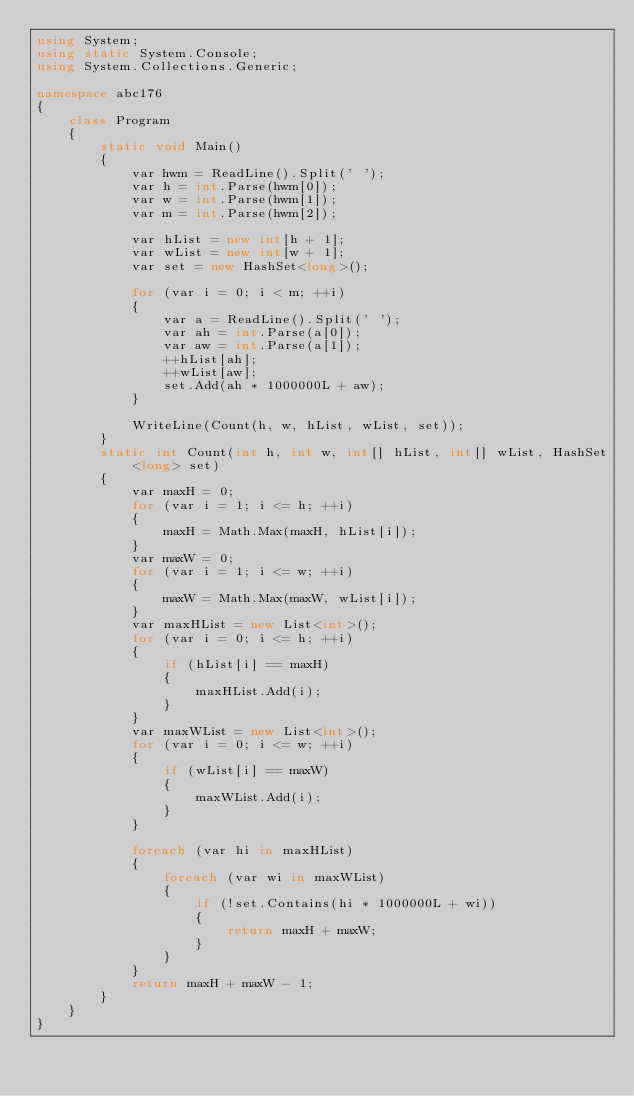<code> <loc_0><loc_0><loc_500><loc_500><_C#_>using System;
using static System.Console;
using System.Collections.Generic;

namespace abc176
{
    class Program
    {
        static void Main()
        {
            var hwm = ReadLine().Split(' ');
            var h = int.Parse(hwm[0]);
            var w = int.Parse(hwm[1]);
            var m = int.Parse(hwm[2]);

            var hList = new int[h + 1];
            var wList = new int[w + 1];
            var set = new HashSet<long>();

            for (var i = 0; i < m; ++i)
            {
                var a = ReadLine().Split(' ');
                var ah = int.Parse(a[0]);
                var aw = int.Parse(a[1]);
                ++hList[ah];
                ++wList[aw];
                set.Add(ah * 1000000L + aw);
            }

            WriteLine(Count(h, w, hList, wList, set));
        }
        static int Count(int h, int w, int[] hList, int[] wList, HashSet<long> set)
        {
            var maxH = 0;
            for (var i = 1; i <= h; ++i)
            {
                maxH = Math.Max(maxH, hList[i]);
            }
            var maxW = 0;
            for (var i = 1; i <= w; ++i)
            {
                maxW = Math.Max(maxW, wList[i]);
            }
            var maxHList = new List<int>();
            for (var i = 0; i <= h; ++i)
            {
                if (hList[i] == maxH)
                {
                    maxHList.Add(i);
                }
            }
            var maxWList = new List<int>();
            for (var i = 0; i <= w; ++i)
            {
                if (wList[i] == maxW)
                {
                    maxWList.Add(i);
                }
            }

            foreach (var hi in maxHList)
            {
                foreach (var wi in maxWList)
                {
                    if (!set.Contains(hi * 1000000L + wi))
                    {
                        return maxH + maxW;
                    }
                }
            }
            return maxH + maxW - 1;
        }
    }
}
</code> 